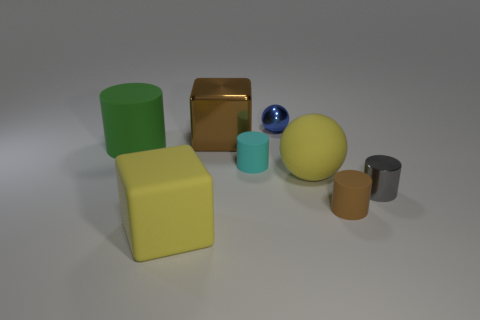Subtract all small metal cylinders. How many cylinders are left? 3 Subtract all gray cylinders. How many cylinders are left? 3 Add 1 yellow rubber cubes. How many objects exist? 9 Subtract all yellow cylinders. Subtract all brown cubes. How many cylinders are left? 4 Subtract all blocks. How many objects are left? 6 Add 2 tiny gray blocks. How many tiny gray blocks exist? 2 Subtract 1 yellow balls. How many objects are left? 7 Subtract all tiny blue shiny things. Subtract all big purple matte cylinders. How many objects are left? 7 Add 6 brown metallic blocks. How many brown metallic blocks are left? 7 